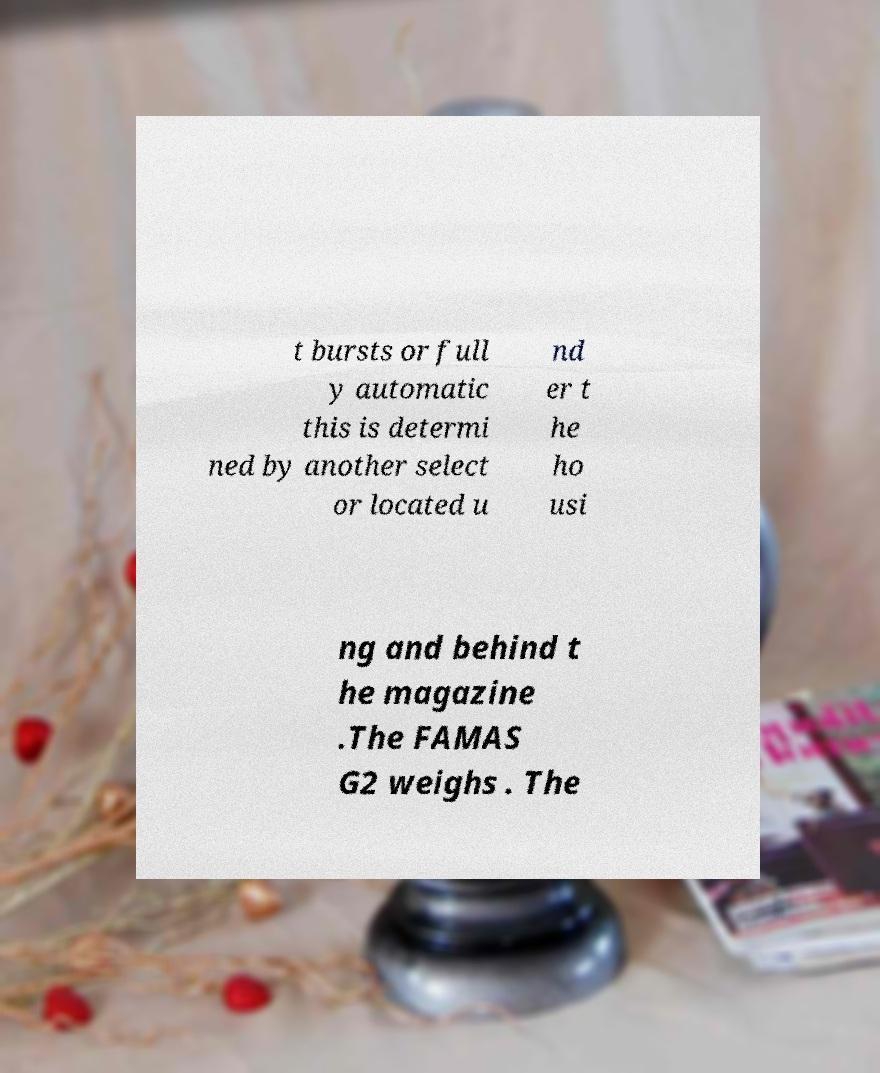Can you read and provide the text displayed in the image?This photo seems to have some interesting text. Can you extract and type it out for me? t bursts or full y automatic this is determi ned by another select or located u nd er t he ho usi ng and behind t he magazine .The FAMAS G2 weighs . The 